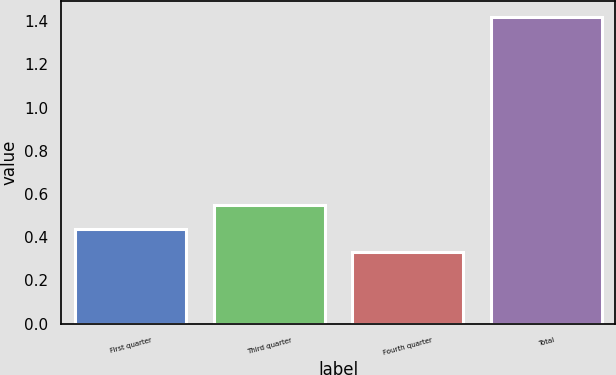Convert chart to OTSL. <chart><loc_0><loc_0><loc_500><loc_500><bar_chart><fcel>First quarter<fcel>Third quarter<fcel>Fourth quarter<fcel>Total<nl><fcel>0.44<fcel>0.55<fcel>0.33<fcel>1.42<nl></chart> 